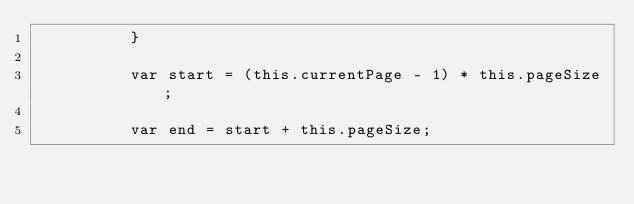<code> <loc_0><loc_0><loc_500><loc_500><_JavaScript_>          }

          var start = (this.currentPage - 1) * this.pageSize;

          var end = start + this.pageSize;
</code> 